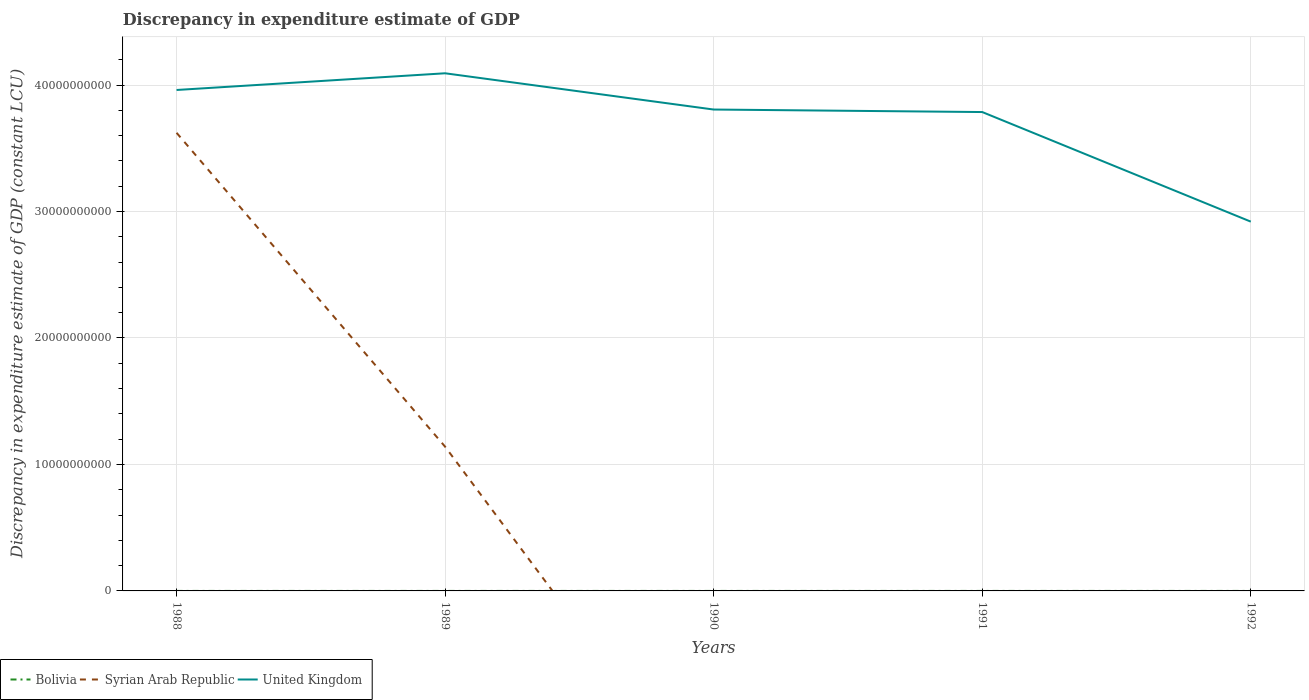How many different coloured lines are there?
Provide a succinct answer. 3. Across all years, what is the maximum discrepancy in expenditure estimate of GDP in Bolivia?
Provide a short and direct response. 0. What is the total discrepancy in expenditure estimate of GDP in United Kingdom in the graph?
Provide a succinct answer. 1.17e+1. What is the difference between the highest and the second highest discrepancy in expenditure estimate of GDP in United Kingdom?
Ensure brevity in your answer.  1.17e+1. What is the difference between the highest and the lowest discrepancy in expenditure estimate of GDP in Bolivia?
Provide a short and direct response. 3. What is the difference between two consecutive major ticks on the Y-axis?
Make the answer very short. 1.00e+1. Does the graph contain grids?
Keep it short and to the point. Yes. Where does the legend appear in the graph?
Ensure brevity in your answer.  Bottom left. How are the legend labels stacked?
Your response must be concise. Horizontal. What is the title of the graph?
Provide a succinct answer. Discrepancy in expenditure estimate of GDP. What is the label or title of the X-axis?
Ensure brevity in your answer.  Years. What is the label or title of the Y-axis?
Offer a very short reply. Discrepancy in expenditure estimate of GDP (constant LCU). What is the Discrepancy in expenditure estimate of GDP (constant LCU) in Syrian Arab Republic in 1988?
Offer a terse response. 3.62e+1. What is the Discrepancy in expenditure estimate of GDP (constant LCU) of United Kingdom in 1988?
Keep it short and to the point. 3.96e+1. What is the Discrepancy in expenditure estimate of GDP (constant LCU) in Bolivia in 1989?
Offer a very short reply. 1200. What is the Discrepancy in expenditure estimate of GDP (constant LCU) in Syrian Arab Republic in 1989?
Make the answer very short. 1.14e+1. What is the Discrepancy in expenditure estimate of GDP (constant LCU) of United Kingdom in 1989?
Provide a succinct answer. 4.09e+1. What is the Discrepancy in expenditure estimate of GDP (constant LCU) of Bolivia in 1990?
Offer a very short reply. 1500. What is the Discrepancy in expenditure estimate of GDP (constant LCU) in Syrian Arab Republic in 1990?
Provide a succinct answer. 0. What is the Discrepancy in expenditure estimate of GDP (constant LCU) in United Kingdom in 1990?
Make the answer very short. 3.81e+1. What is the Discrepancy in expenditure estimate of GDP (constant LCU) in United Kingdom in 1991?
Give a very brief answer. 3.79e+1. What is the Discrepancy in expenditure estimate of GDP (constant LCU) of Bolivia in 1992?
Provide a succinct answer. 1200. What is the Discrepancy in expenditure estimate of GDP (constant LCU) in United Kingdom in 1992?
Provide a succinct answer. 2.92e+1. Across all years, what is the maximum Discrepancy in expenditure estimate of GDP (constant LCU) of Bolivia?
Your answer should be very brief. 1500. Across all years, what is the maximum Discrepancy in expenditure estimate of GDP (constant LCU) of Syrian Arab Republic?
Your response must be concise. 3.62e+1. Across all years, what is the maximum Discrepancy in expenditure estimate of GDP (constant LCU) in United Kingdom?
Your answer should be very brief. 4.09e+1. Across all years, what is the minimum Discrepancy in expenditure estimate of GDP (constant LCU) in Syrian Arab Republic?
Give a very brief answer. 0. Across all years, what is the minimum Discrepancy in expenditure estimate of GDP (constant LCU) of United Kingdom?
Offer a terse response. 2.92e+1. What is the total Discrepancy in expenditure estimate of GDP (constant LCU) of Bolivia in the graph?
Offer a very short reply. 3900. What is the total Discrepancy in expenditure estimate of GDP (constant LCU) of Syrian Arab Republic in the graph?
Your response must be concise. 4.76e+1. What is the total Discrepancy in expenditure estimate of GDP (constant LCU) of United Kingdom in the graph?
Keep it short and to the point. 1.86e+11. What is the difference between the Discrepancy in expenditure estimate of GDP (constant LCU) of Syrian Arab Republic in 1988 and that in 1989?
Give a very brief answer. 2.48e+1. What is the difference between the Discrepancy in expenditure estimate of GDP (constant LCU) in United Kingdom in 1988 and that in 1989?
Your response must be concise. -1.32e+09. What is the difference between the Discrepancy in expenditure estimate of GDP (constant LCU) of United Kingdom in 1988 and that in 1990?
Offer a terse response. 1.55e+09. What is the difference between the Discrepancy in expenditure estimate of GDP (constant LCU) of United Kingdom in 1988 and that in 1991?
Your answer should be compact. 1.74e+09. What is the difference between the Discrepancy in expenditure estimate of GDP (constant LCU) in United Kingdom in 1988 and that in 1992?
Offer a very short reply. 1.04e+1. What is the difference between the Discrepancy in expenditure estimate of GDP (constant LCU) in Bolivia in 1989 and that in 1990?
Offer a very short reply. -300. What is the difference between the Discrepancy in expenditure estimate of GDP (constant LCU) in United Kingdom in 1989 and that in 1990?
Make the answer very short. 2.87e+09. What is the difference between the Discrepancy in expenditure estimate of GDP (constant LCU) in United Kingdom in 1989 and that in 1991?
Offer a terse response. 3.06e+09. What is the difference between the Discrepancy in expenditure estimate of GDP (constant LCU) in United Kingdom in 1989 and that in 1992?
Give a very brief answer. 1.17e+1. What is the difference between the Discrepancy in expenditure estimate of GDP (constant LCU) of United Kingdom in 1990 and that in 1991?
Ensure brevity in your answer.  1.98e+08. What is the difference between the Discrepancy in expenditure estimate of GDP (constant LCU) in Bolivia in 1990 and that in 1992?
Ensure brevity in your answer.  300. What is the difference between the Discrepancy in expenditure estimate of GDP (constant LCU) in United Kingdom in 1990 and that in 1992?
Keep it short and to the point. 8.87e+09. What is the difference between the Discrepancy in expenditure estimate of GDP (constant LCU) in United Kingdom in 1991 and that in 1992?
Offer a very short reply. 8.67e+09. What is the difference between the Discrepancy in expenditure estimate of GDP (constant LCU) in Syrian Arab Republic in 1988 and the Discrepancy in expenditure estimate of GDP (constant LCU) in United Kingdom in 1989?
Offer a very short reply. -4.71e+09. What is the difference between the Discrepancy in expenditure estimate of GDP (constant LCU) of Syrian Arab Republic in 1988 and the Discrepancy in expenditure estimate of GDP (constant LCU) of United Kingdom in 1990?
Make the answer very short. -1.84e+09. What is the difference between the Discrepancy in expenditure estimate of GDP (constant LCU) of Syrian Arab Republic in 1988 and the Discrepancy in expenditure estimate of GDP (constant LCU) of United Kingdom in 1991?
Your answer should be very brief. -1.64e+09. What is the difference between the Discrepancy in expenditure estimate of GDP (constant LCU) of Syrian Arab Republic in 1988 and the Discrepancy in expenditure estimate of GDP (constant LCU) of United Kingdom in 1992?
Make the answer very short. 7.03e+09. What is the difference between the Discrepancy in expenditure estimate of GDP (constant LCU) in Bolivia in 1989 and the Discrepancy in expenditure estimate of GDP (constant LCU) in United Kingdom in 1990?
Make the answer very short. -3.81e+1. What is the difference between the Discrepancy in expenditure estimate of GDP (constant LCU) in Syrian Arab Republic in 1989 and the Discrepancy in expenditure estimate of GDP (constant LCU) in United Kingdom in 1990?
Offer a terse response. -2.67e+1. What is the difference between the Discrepancy in expenditure estimate of GDP (constant LCU) in Bolivia in 1989 and the Discrepancy in expenditure estimate of GDP (constant LCU) in United Kingdom in 1991?
Your response must be concise. -3.79e+1. What is the difference between the Discrepancy in expenditure estimate of GDP (constant LCU) of Syrian Arab Republic in 1989 and the Discrepancy in expenditure estimate of GDP (constant LCU) of United Kingdom in 1991?
Provide a short and direct response. -2.65e+1. What is the difference between the Discrepancy in expenditure estimate of GDP (constant LCU) of Bolivia in 1989 and the Discrepancy in expenditure estimate of GDP (constant LCU) of United Kingdom in 1992?
Ensure brevity in your answer.  -2.92e+1. What is the difference between the Discrepancy in expenditure estimate of GDP (constant LCU) of Syrian Arab Republic in 1989 and the Discrepancy in expenditure estimate of GDP (constant LCU) of United Kingdom in 1992?
Keep it short and to the point. -1.78e+1. What is the difference between the Discrepancy in expenditure estimate of GDP (constant LCU) of Bolivia in 1990 and the Discrepancy in expenditure estimate of GDP (constant LCU) of United Kingdom in 1991?
Provide a succinct answer. -3.79e+1. What is the difference between the Discrepancy in expenditure estimate of GDP (constant LCU) in Bolivia in 1990 and the Discrepancy in expenditure estimate of GDP (constant LCU) in United Kingdom in 1992?
Ensure brevity in your answer.  -2.92e+1. What is the average Discrepancy in expenditure estimate of GDP (constant LCU) in Bolivia per year?
Give a very brief answer. 780. What is the average Discrepancy in expenditure estimate of GDP (constant LCU) in Syrian Arab Republic per year?
Your response must be concise. 9.53e+09. What is the average Discrepancy in expenditure estimate of GDP (constant LCU) in United Kingdom per year?
Your answer should be very brief. 3.71e+1. In the year 1988, what is the difference between the Discrepancy in expenditure estimate of GDP (constant LCU) in Syrian Arab Republic and Discrepancy in expenditure estimate of GDP (constant LCU) in United Kingdom?
Make the answer very short. -3.39e+09. In the year 1989, what is the difference between the Discrepancy in expenditure estimate of GDP (constant LCU) of Bolivia and Discrepancy in expenditure estimate of GDP (constant LCU) of Syrian Arab Republic?
Make the answer very short. -1.14e+1. In the year 1989, what is the difference between the Discrepancy in expenditure estimate of GDP (constant LCU) of Bolivia and Discrepancy in expenditure estimate of GDP (constant LCU) of United Kingdom?
Ensure brevity in your answer.  -4.09e+1. In the year 1989, what is the difference between the Discrepancy in expenditure estimate of GDP (constant LCU) in Syrian Arab Republic and Discrepancy in expenditure estimate of GDP (constant LCU) in United Kingdom?
Make the answer very short. -2.95e+1. In the year 1990, what is the difference between the Discrepancy in expenditure estimate of GDP (constant LCU) in Bolivia and Discrepancy in expenditure estimate of GDP (constant LCU) in United Kingdom?
Provide a short and direct response. -3.81e+1. In the year 1992, what is the difference between the Discrepancy in expenditure estimate of GDP (constant LCU) in Bolivia and Discrepancy in expenditure estimate of GDP (constant LCU) in United Kingdom?
Provide a succinct answer. -2.92e+1. What is the ratio of the Discrepancy in expenditure estimate of GDP (constant LCU) of Syrian Arab Republic in 1988 to that in 1989?
Keep it short and to the point. 3.18. What is the ratio of the Discrepancy in expenditure estimate of GDP (constant LCU) of United Kingdom in 1988 to that in 1989?
Provide a succinct answer. 0.97. What is the ratio of the Discrepancy in expenditure estimate of GDP (constant LCU) of United Kingdom in 1988 to that in 1990?
Offer a terse response. 1.04. What is the ratio of the Discrepancy in expenditure estimate of GDP (constant LCU) of United Kingdom in 1988 to that in 1991?
Give a very brief answer. 1.05. What is the ratio of the Discrepancy in expenditure estimate of GDP (constant LCU) of United Kingdom in 1988 to that in 1992?
Provide a short and direct response. 1.36. What is the ratio of the Discrepancy in expenditure estimate of GDP (constant LCU) of Bolivia in 1989 to that in 1990?
Keep it short and to the point. 0.8. What is the ratio of the Discrepancy in expenditure estimate of GDP (constant LCU) in United Kingdom in 1989 to that in 1990?
Provide a short and direct response. 1.08. What is the ratio of the Discrepancy in expenditure estimate of GDP (constant LCU) of United Kingdom in 1989 to that in 1991?
Offer a very short reply. 1.08. What is the ratio of the Discrepancy in expenditure estimate of GDP (constant LCU) in United Kingdom in 1989 to that in 1992?
Your answer should be compact. 1.4. What is the ratio of the Discrepancy in expenditure estimate of GDP (constant LCU) of United Kingdom in 1990 to that in 1992?
Your answer should be compact. 1.3. What is the ratio of the Discrepancy in expenditure estimate of GDP (constant LCU) in United Kingdom in 1991 to that in 1992?
Offer a very short reply. 1.3. What is the difference between the highest and the second highest Discrepancy in expenditure estimate of GDP (constant LCU) in Bolivia?
Your answer should be very brief. 300. What is the difference between the highest and the second highest Discrepancy in expenditure estimate of GDP (constant LCU) of United Kingdom?
Give a very brief answer. 1.32e+09. What is the difference between the highest and the lowest Discrepancy in expenditure estimate of GDP (constant LCU) of Bolivia?
Make the answer very short. 1500. What is the difference between the highest and the lowest Discrepancy in expenditure estimate of GDP (constant LCU) of Syrian Arab Republic?
Make the answer very short. 3.62e+1. What is the difference between the highest and the lowest Discrepancy in expenditure estimate of GDP (constant LCU) of United Kingdom?
Your response must be concise. 1.17e+1. 